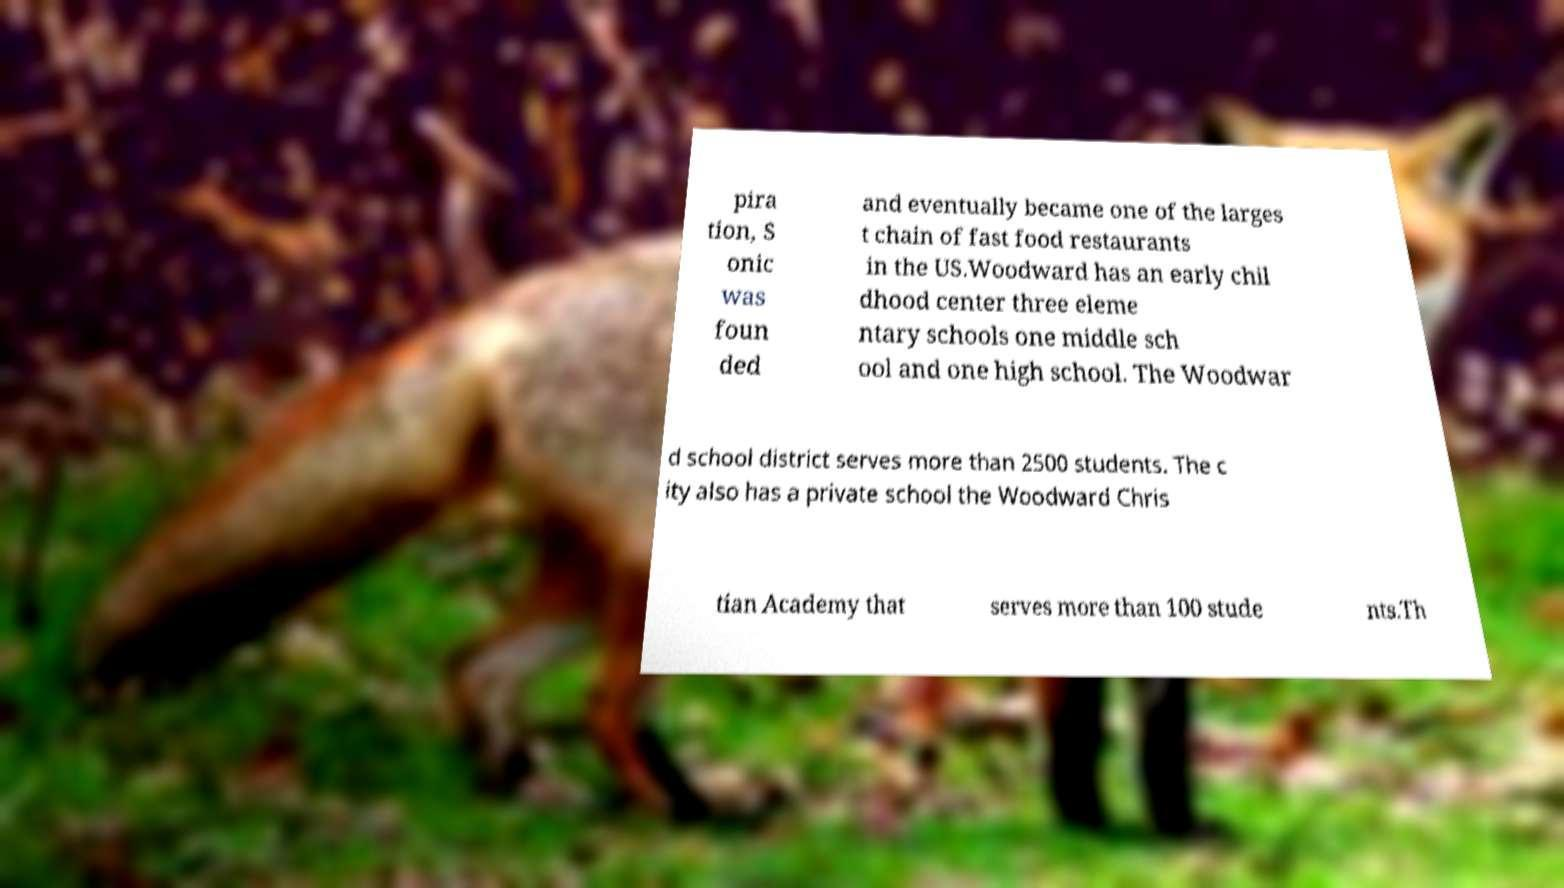I need the written content from this picture converted into text. Can you do that? pira tion, S onic was foun ded and eventually became one of the larges t chain of fast food restaurants in the US.Woodward has an early chil dhood center three eleme ntary schools one middle sch ool and one high school. The Woodwar d school district serves more than 2500 students. The c ity also has a private school the Woodward Chris tian Academy that serves more than 100 stude nts.Th 